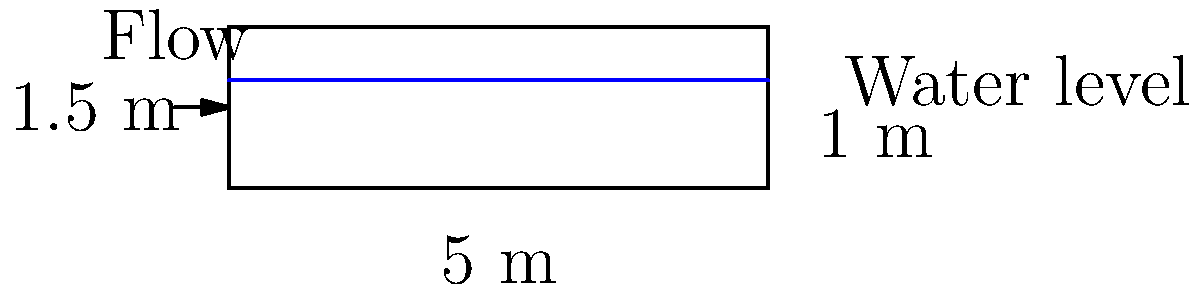In a linguistic analysis of Tolkien's works, you encounter a metaphor comparing the flow of ideas to water through a culvert. To better understand this metaphor, consider a rectangular culvert with the following dimensions: 5 m wide, 1.5 m high, and a water depth of 1 m. If the average velocity of the water is 2 m/s, what is the flow rate through the culvert in cubic meters per second (m³/s)? To calculate the flow rate through the culvert, we'll follow these steps:

1. Determine the cross-sectional area of the water flow:
   The width of the culvert is 5 m, and the depth of water is 1 m.
   Area = width × depth
   $$A = 5 \text{ m} \times 1 \text{ m} = 5 \text{ m}^2$$

2. Recall the flow rate equation:
   Flow rate = Cross-sectional area × Velocity
   $$Q = A \times v$$

3. Insert the known values:
   A = 5 m²
   v = 2 m/s
   $$Q = 5 \text{ m}^2 \times 2 \text{ m/s}$$

4. Calculate the flow rate:
   $$Q = 10 \text{ m}^3/\text{s}$$

This metaphorical flow rate could be interpreted as the rate at which ideas or linguistic elements traverse through Tolkien's narratives, much like water through a culvert.
Answer: 10 m³/s 